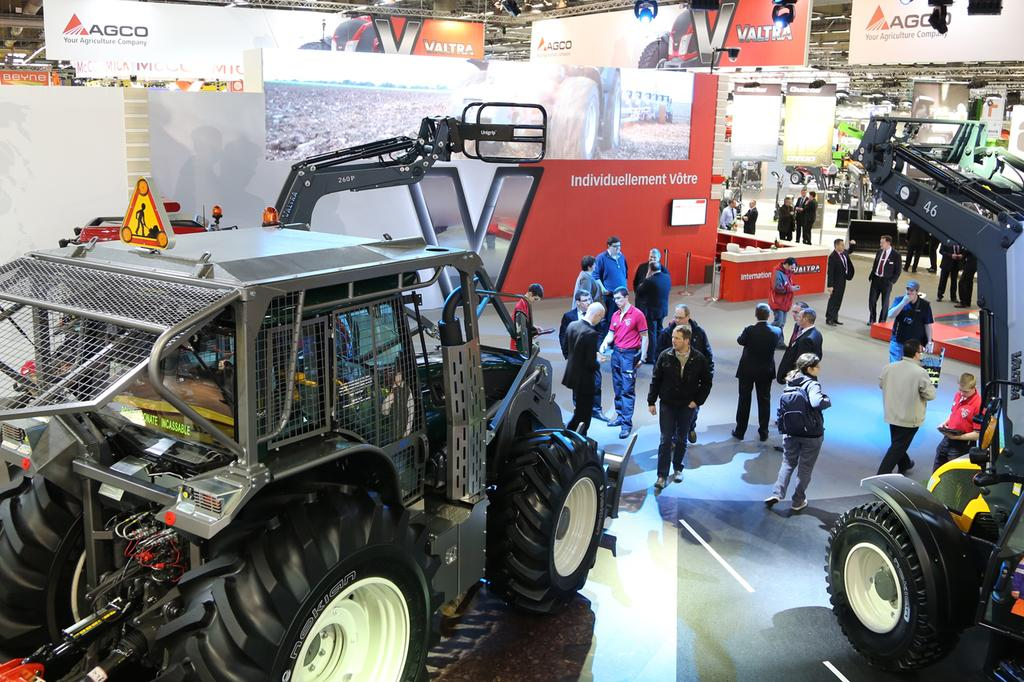How many vehicles are present in the image? There are two vehicles in the image. Can you describe the people in the image? There are persons in the image. What type of furniture is visible in the image? There is a table in the image. What is the purpose of the holding board in the image? The holding board contains images of persons and text. Where is the stamp located in the image? There is no stamp present in the image. What shape is the hall in the image? There is no hall present in the image. 